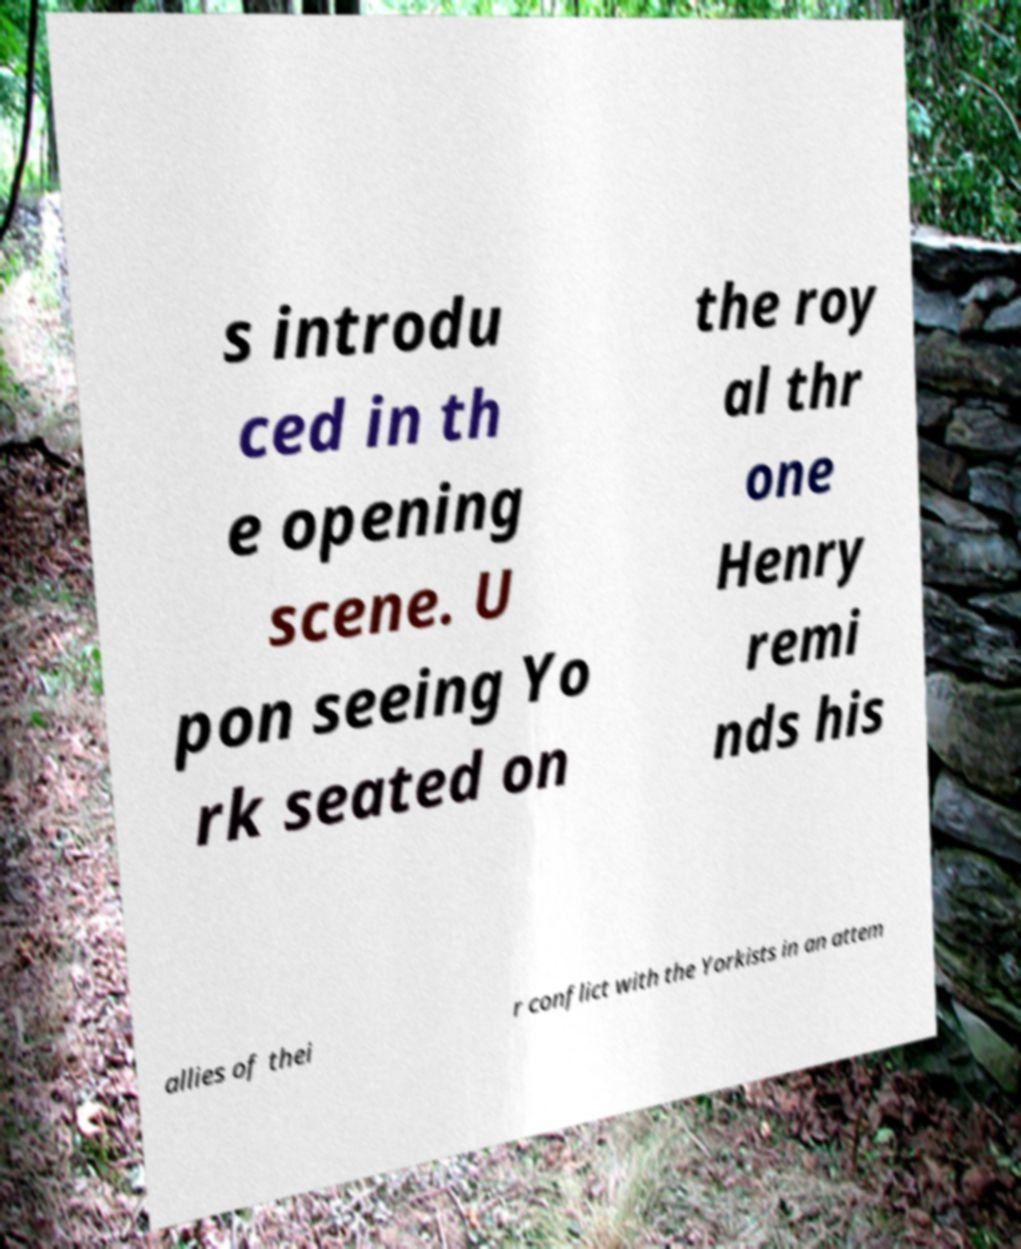There's text embedded in this image that I need extracted. Can you transcribe it verbatim? s introdu ced in th e opening scene. U pon seeing Yo rk seated on the roy al thr one Henry remi nds his allies of thei r conflict with the Yorkists in an attem 